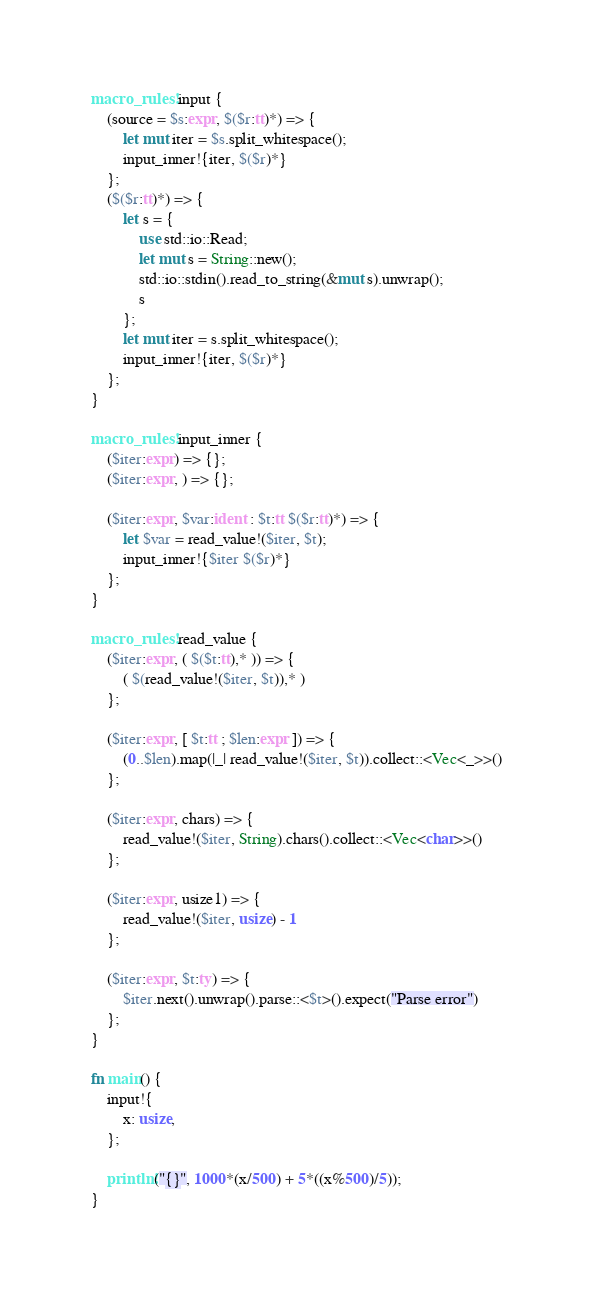<code> <loc_0><loc_0><loc_500><loc_500><_Rust_>macro_rules! input {
    (source = $s:expr, $($r:tt)*) => {
        let mut iter = $s.split_whitespace();
        input_inner!{iter, $($r)*}
    };
    ($($r:tt)*) => {
        let s = {
            use std::io::Read;
            let mut s = String::new();
            std::io::stdin().read_to_string(&mut s).unwrap();
            s
        };
        let mut iter = s.split_whitespace();
        input_inner!{iter, $($r)*}
    };
}

macro_rules! input_inner {
    ($iter:expr) => {};
    ($iter:expr, ) => {};

    ($iter:expr, $var:ident : $t:tt $($r:tt)*) => {
        let $var = read_value!($iter, $t);
        input_inner!{$iter $($r)*}
    };
}

macro_rules! read_value {
    ($iter:expr, ( $($t:tt),* )) => {
        ( $(read_value!($iter, $t)),* )
    };

    ($iter:expr, [ $t:tt ; $len:expr ]) => {
        (0..$len).map(|_| read_value!($iter, $t)).collect::<Vec<_>>()
    };

    ($iter:expr, chars) => {
        read_value!($iter, String).chars().collect::<Vec<char>>()
    };

    ($iter:expr, usize1) => {
        read_value!($iter, usize) - 1
    };

    ($iter:expr, $t:ty) => {
        $iter.next().unwrap().parse::<$t>().expect("Parse error")
    };
}

fn main() {
    input!{
        x: usize,
    };

    println!("{}", 1000*(x/500) + 5*((x%500)/5));
}
</code> 